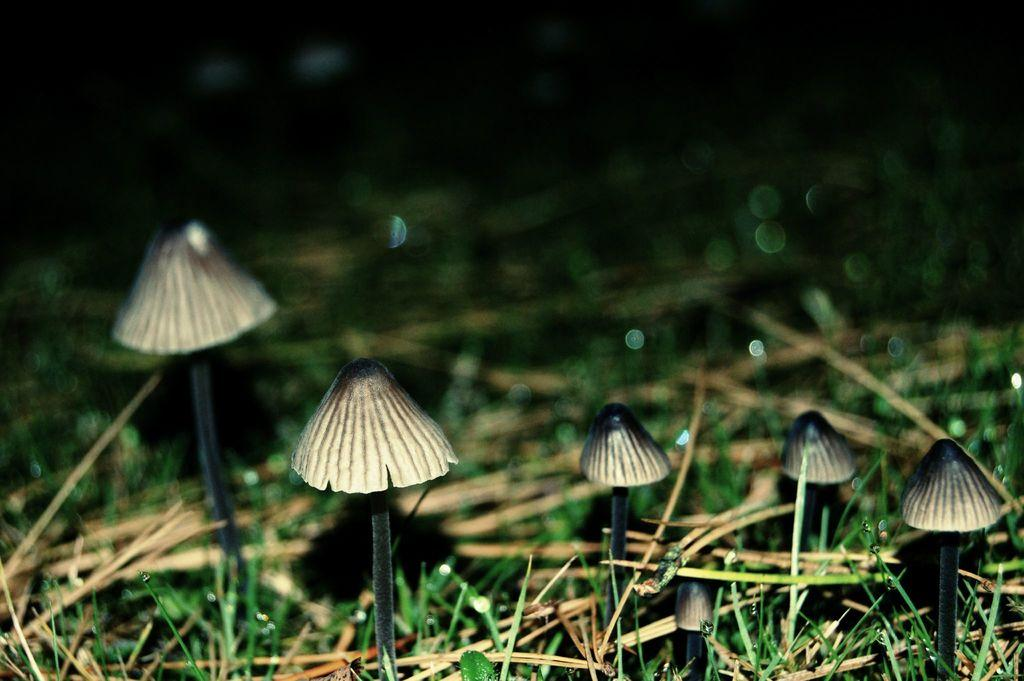What type of vegetation can be seen in the image? There are mushrooms and grass in the image. Can you describe the condition of the grass in the image? There is dry grass in the image. What can be observed about the background of the image? The background of the image is blurred. What type of quill can be seen in the image? There is no quill present in the image. How is the dirt distributed in the image? There is no dirt present in the image. 